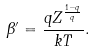Convert formula to latex. <formula><loc_0><loc_0><loc_500><loc_500>\beta ^ { \prime } = \frac { q Z ^ { \frac { 1 - q } { q } } } { k T } .</formula> 